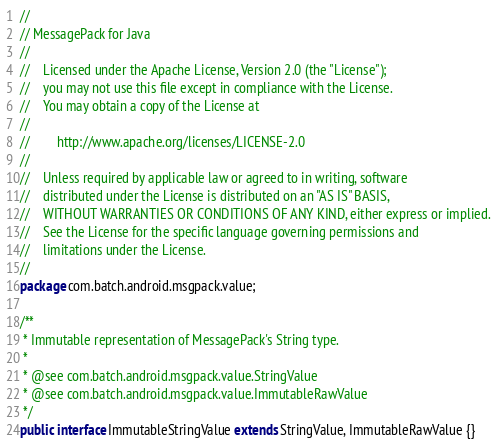Convert code to text. <code><loc_0><loc_0><loc_500><loc_500><_Java_>//
// MessagePack for Java
//
//    Licensed under the Apache License, Version 2.0 (the "License");
//    you may not use this file except in compliance with the License.
//    You may obtain a copy of the License at
//
//        http://www.apache.org/licenses/LICENSE-2.0
//
//    Unless required by applicable law or agreed to in writing, software
//    distributed under the License is distributed on an "AS IS" BASIS,
//    WITHOUT WARRANTIES OR CONDITIONS OF ANY KIND, either express or implied.
//    See the License for the specific language governing permissions and
//    limitations under the License.
//
package com.batch.android.msgpack.value;

/**
 * Immutable representation of MessagePack's String type.
 *
 * @see com.batch.android.msgpack.value.StringValue
 * @see com.batch.android.msgpack.value.ImmutableRawValue
 */
public interface ImmutableStringValue extends StringValue, ImmutableRawValue {}
</code> 